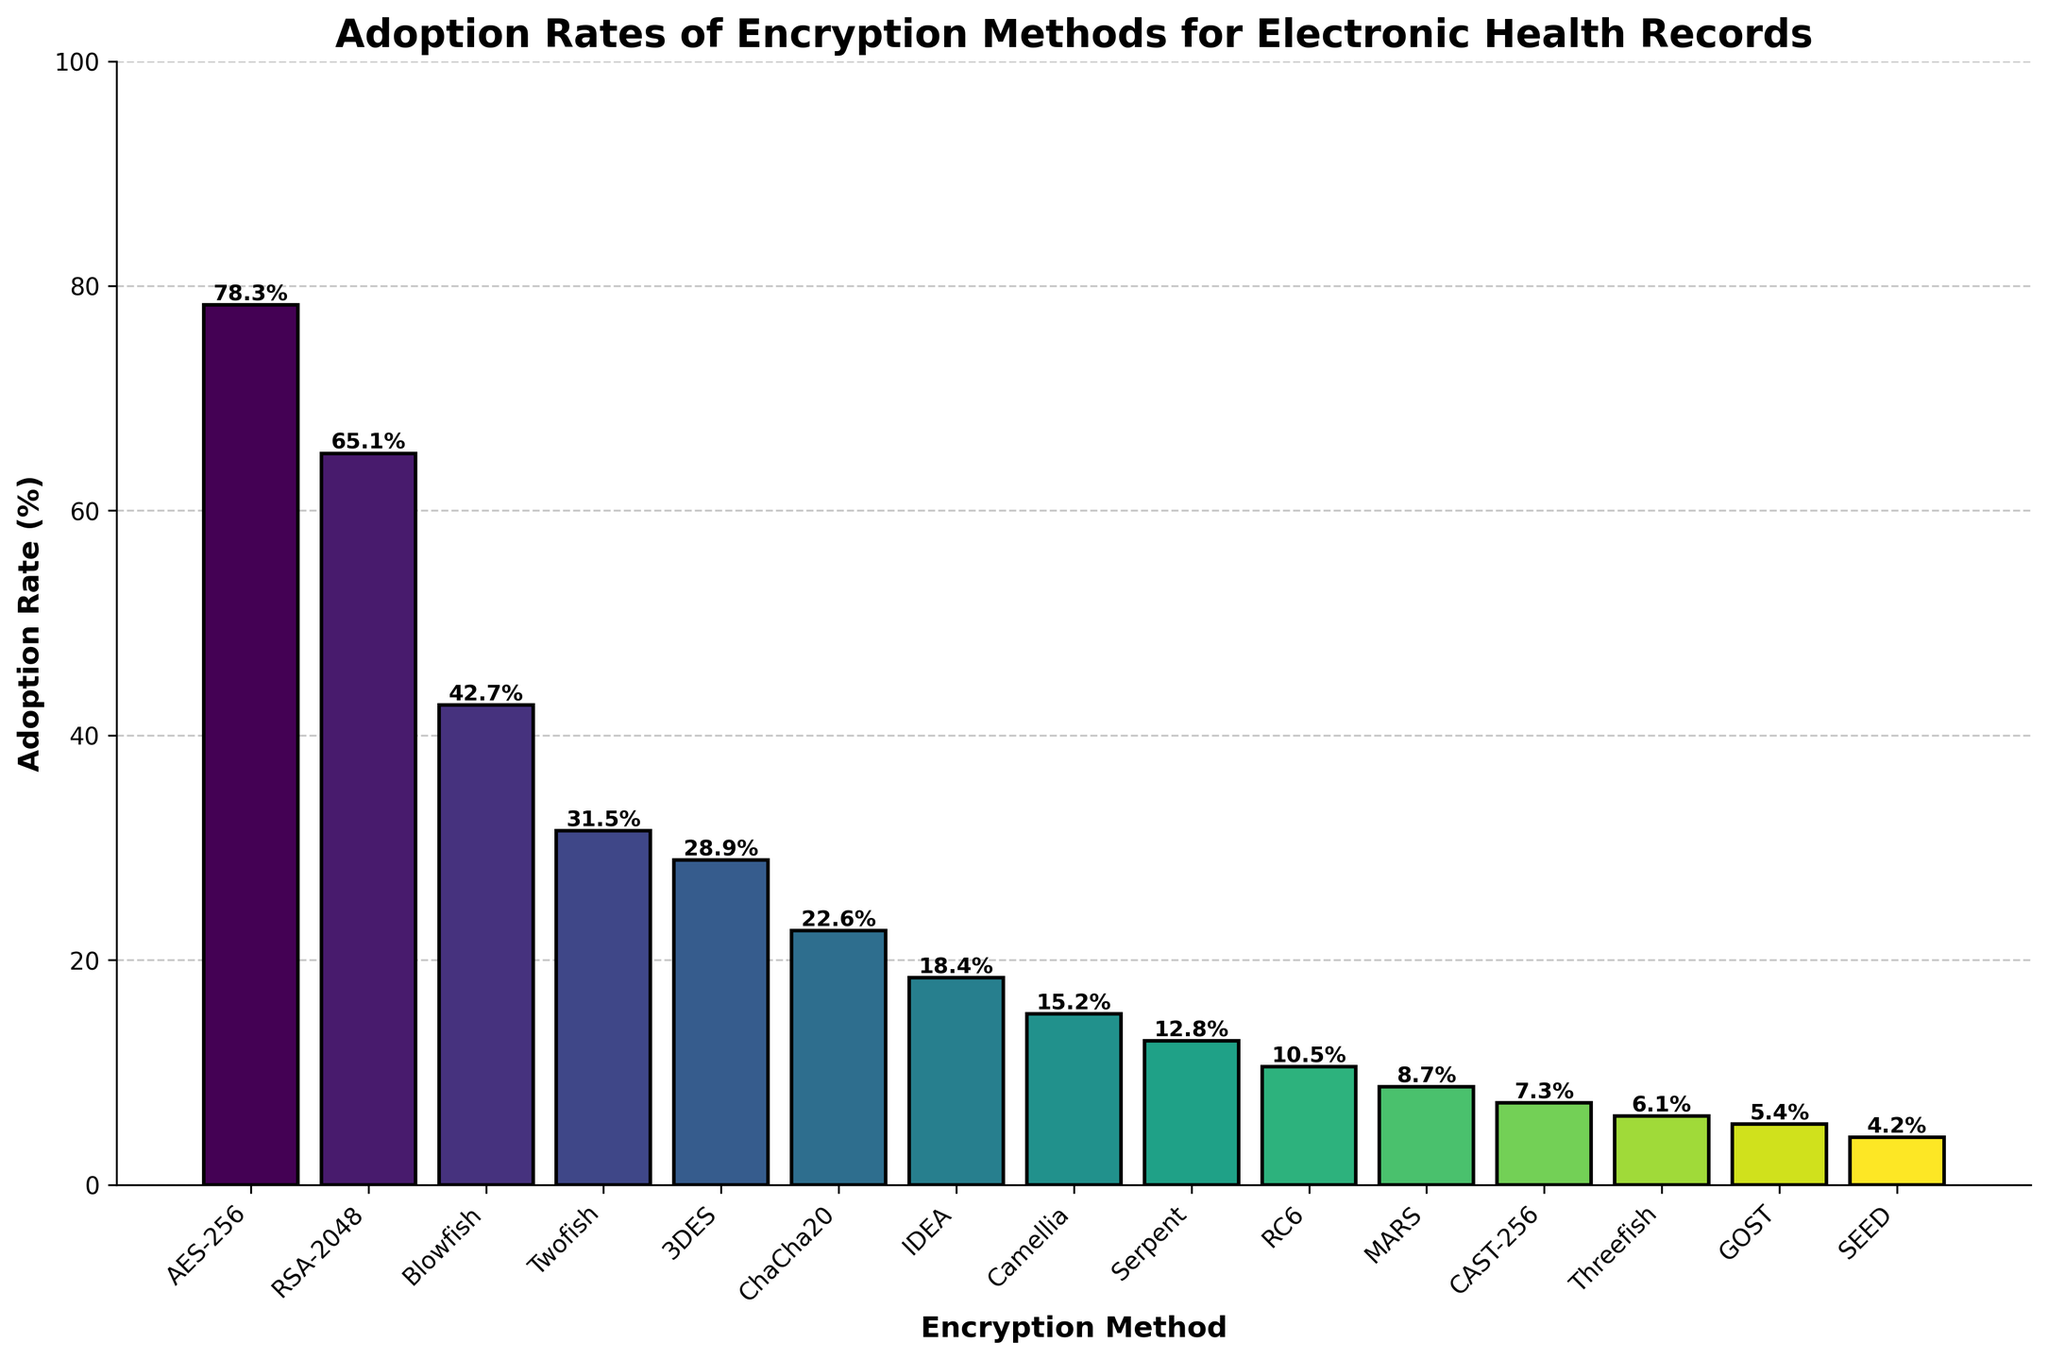What is the most commonly used encryption method? The height of the bar representing AES-256 is the tallest, indicating the highest adoption rate.
Answer: AES-256 Which encryption method has the lowest adoption rate? The bar representing SEED is the shortest, indicating the lowest adoption rate.
Answer: SEED What is the combined adoption rate of AES-256 and RSA-2048? The adoption rate of AES-256 is 78.3% and for RSA-2048 is 65.1%. Adding these together gives 143.4%.
Answer: 143.4% Which encryption methods have adoption rates above 50%? AES-256 has an adoption rate of 78.3%, and RSA-2048 has 65.1%, both greater than 50%.
Answer: AES-256, RSA-2048 How much higher is the adoption rate of Blowfish compared to ChaCha20? The adoption rate of Blowfish is 42.7% and ChaCha20 is 22.6%. The difference is 42.7% - 22.6% = 20.1%.
Answer: 20.1% Which encryption method is the third least adopted? The bars representing Serpent, RC6, and MARS are the shortest after SEED and GOST. MARS has an adoption rate of 8.7%, which is the third least.
Answer: MARS What is the average adoption rate of the four most adopted encryption methods? The four most adopted methods are AES-256 (78.3%), RSA-2048 (65.1%), Blowfish (42.7%), and Twofish (31.5%). Their sum is 78.3 + 65.1 + 42.7 + 31.5 = 217.6. The average is 217.6 / 4 = 54.4%.
Answer: 54.4% Is the adoption rate of 3DES higher or lower than that of Twofish? Comparing the bars, Twofish has an adoption rate of 31.5%, and 3DES has 28.9%, so 3DES is lower.
Answer: Lower What is the difference between the adoption rates of the most and least adopted encryption methods? The most adopted method is AES-256 with 78.3%, and the least adopted is SEED with 4.2%. The difference is 78.3% - 4.2% = 74.1%.
Answer: 74.1% Which encryption methods have adoption rates between 10% and 20%? IDEA, Camellia, and Serpent have adoption rates of 18.4%, 15.2%, and 12.8% respectively, all lying between 10% and 20%.
Answer: IDEA, Camellia, Serpent 